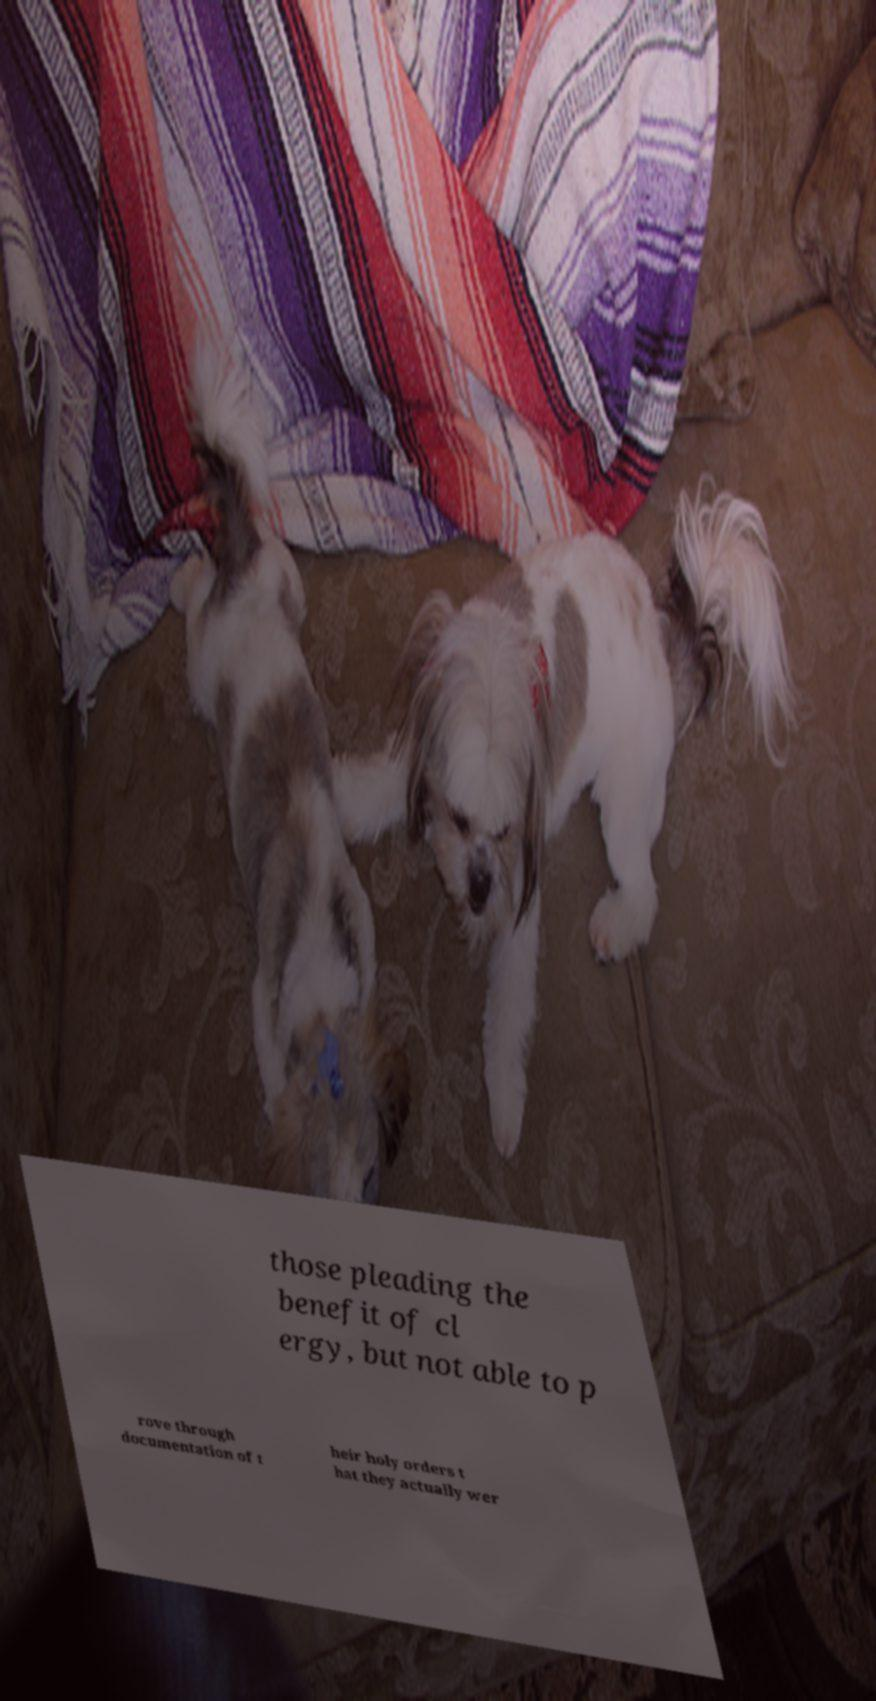Could you extract and type out the text from this image? those pleading the benefit of cl ergy, but not able to p rove through documentation of t heir holy orders t hat they actually wer 